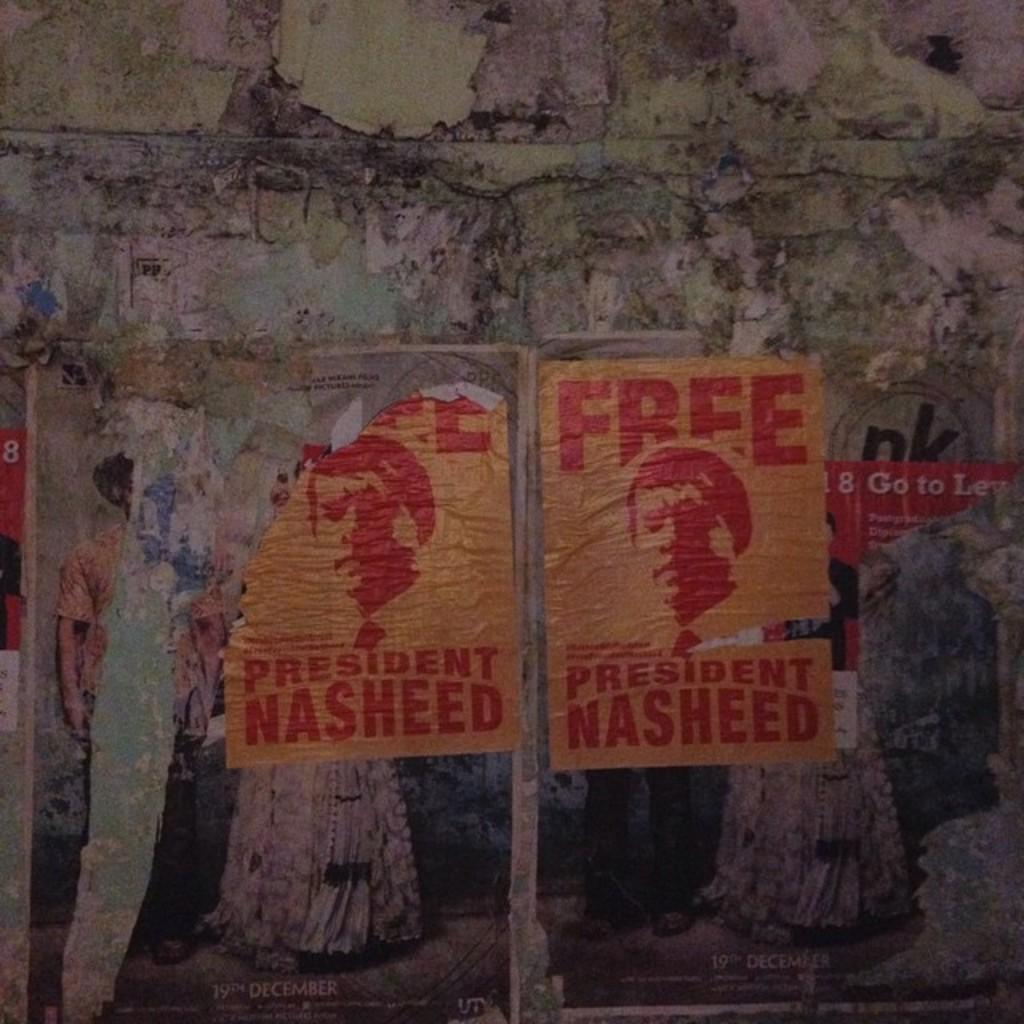Who does the sign say needs to be freed?
Offer a terse response. President nasheed. Who is the president?
Your answer should be very brief. Nasheed. 